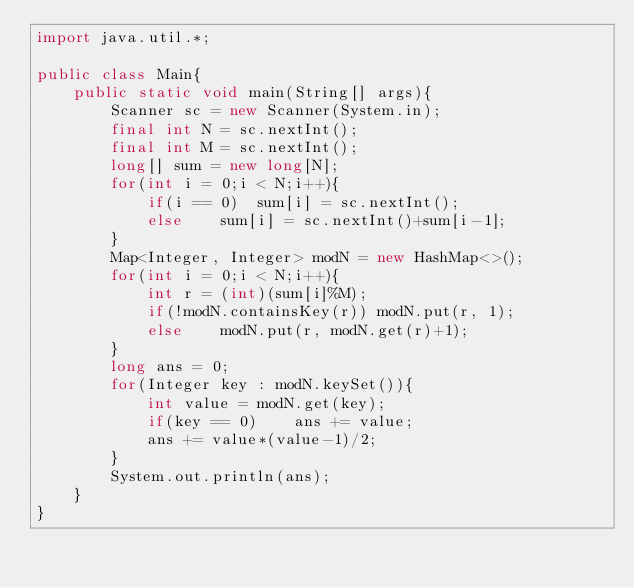Convert code to text. <code><loc_0><loc_0><loc_500><loc_500><_Java_>import java.util.*;

public class Main{
    public static void main(String[] args){
        Scanner sc = new Scanner(System.in);
        final int N = sc.nextInt();
        final int M = sc.nextInt();
        long[] sum = new long[N];
        for(int i = 0;i < N;i++){
            if(i == 0)  sum[i] = sc.nextInt();
            else    sum[i] = sc.nextInt()+sum[i-1];
        }
        Map<Integer, Integer> modN = new HashMap<>();
        for(int i = 0;i < N;i++){
            int r = (int)(sum[i]%M);
            if(!modN.containsKey(r)) modN.put(r, 1);
            else    modN.put(r, modN.get(r)+1);
        }
        long ans = 0;
        for(Integer key : modN.keySet()){
            int value = modN.get(key);
            if(key == 0)    ans += value;
            ans += value*(value-1)/2;
        }
        System.out.println(ans);
    }
}</code> 